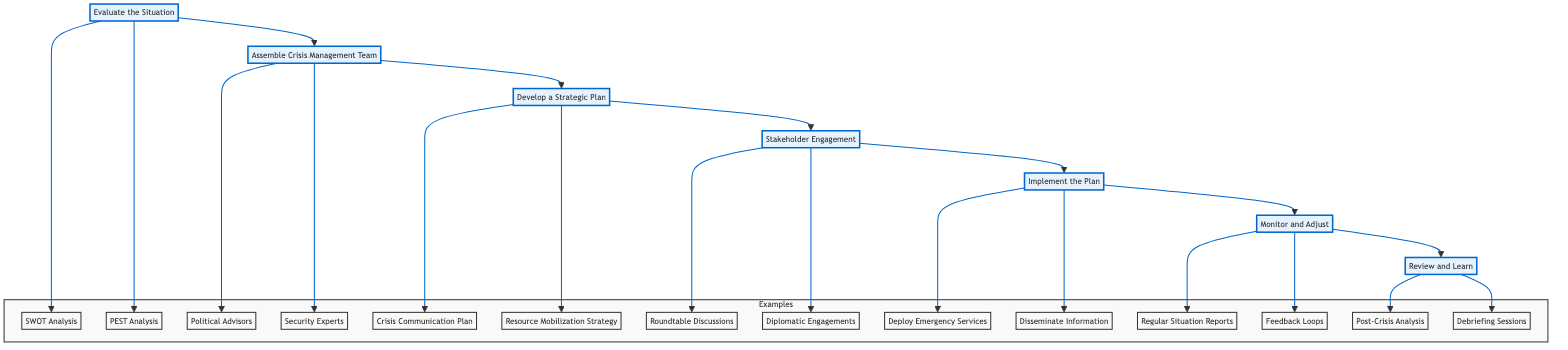What is the first step in the crisis management flow? The diagram indicates that the first step is "Evaluate the Situation," as it is the starting point of the process.
Answer: Evaluate the Situation How many main steps are there in the crisis management process? By counting the main elements in the flowchart, we see there are six main steps listed from "Evaluate the Situation" to "Review and Learn."
Answer: Six What follows after "Develop a Strategic Plan"? The flowchart shows that the step immediately following "Develop a Strategic Plan" is "Stakeholder Engagement."
Answer: Stakeholder Engagement What type of examples are associated with the step “Assemble Crisis Management Team”? According to the diagram, examples related to this step include "Political Advisors" and "Security Experts."
Answer: Political Advisors, Security Experts Which final step involves learning from the crisis? The last step in the diagram, which focuses on learning and reflecting, is "Review and Learn."
Answer: Review and Learn How does the flow between "Implement the Plan" and "Monitor and Adjust" work in terms of direction? The diagram illustrates a clear downward flow from "Implement the Plan" to "Monitor and Adjust," indicating that monitoring follows implementation.
Answer: Downward flow What is the relationship between "Stakeholder Engagement" and "Implement the Plan"? The relationship indicates that "Stakeholder Engagement" must occur prior to "Implement the Plan," as it directly feeds into the implementation phase.
Answer: Stakeholder Engagement must happen before Implement the Plan What kind of analysis is included under "Evaluate the Situation"? The diagram specifies two types of analyses: "SWOT Analysis" and "PEST Analysis."
Answer: SWOT Analysis, PEST Analysis 